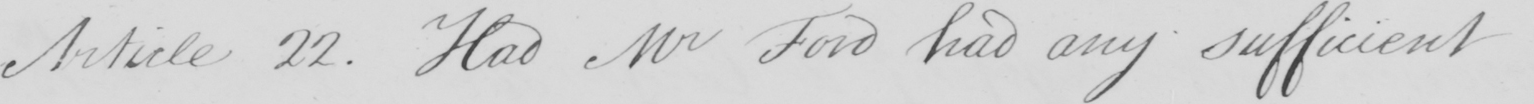What does this handwritten line say? Article 22 . Had Mr Ford had any sufficient 